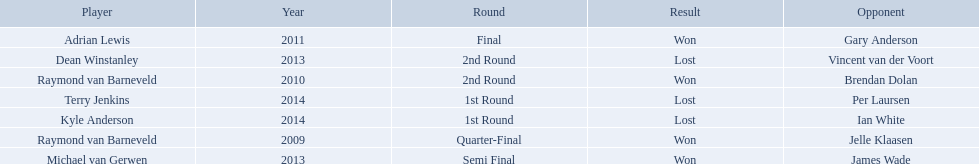What was the names of all the players? Raymond van Barneveld, Raymond van Barneveld, Adrian Lewis, Dean Winstanley, Michael van Gerwen, Terry Jenkins, Kyle Anderson. What years were the championship offered? 2009, 2010, 2011, 2013, 2013, 2014, 2014. Of these, who played in 2011? Adrian Lewis. Who are the players listed? Raymond van Barneveld, Raymond van Barneveld, Adrian Lewis, Dean Winstanley, Michael van Gerwen, Terry Jenkins, Kyle Anderson. Which of these players played in 2011? Adrian Lewis. What are all the years? 2009, 2010, 2011, 2013, 2013, 2014, 2014. Of these, which ones are 2014? 2014, 2014. Of these dates which one is associated with a player other than kyle anderson? 2014. What is the player name associated with this year? Terry Jenkins. 